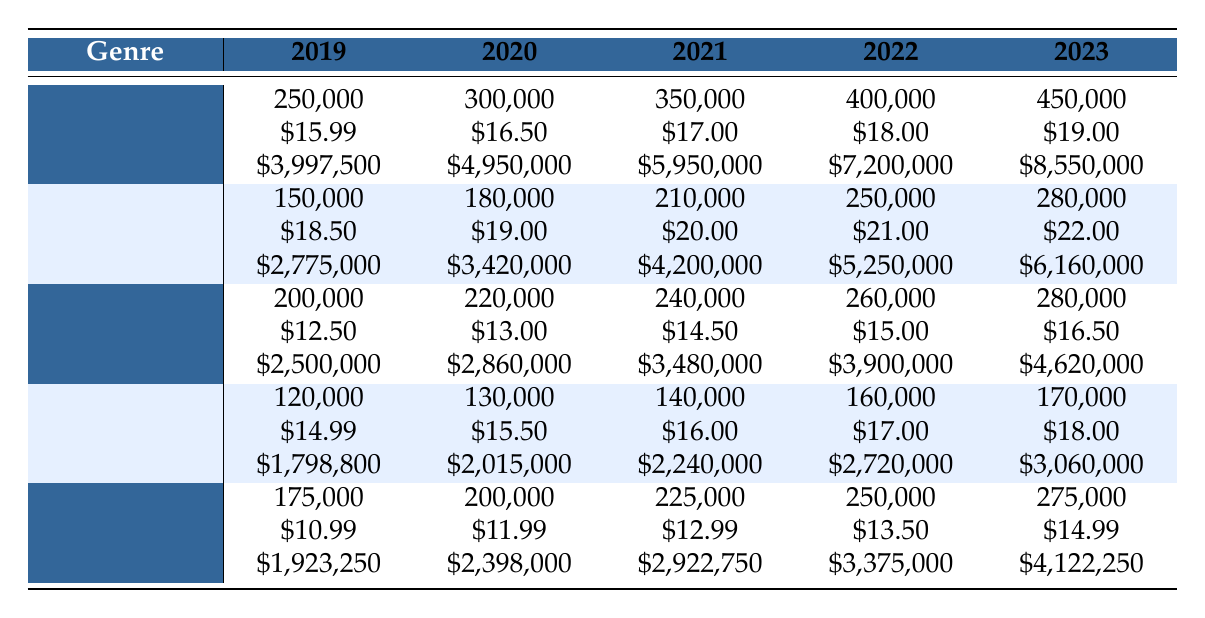What was the total revenue from Fiction sales in 2022? The revenue for Fiction in 2022 is listed directly in the table. According to the table, the revenue for Fiction in 2022 was \$7,200,000.
Answer: 7200000 Which genre had the lowest sales units in 2019? The sales units for each genre in 2019 are presented in the table. Fiction sold 250,000, Non-Fiction sold 150,000, Fantasy sold 200,000, Mystery sold 120,000, and Young Adult sold 175,000. Mystery had the lowest sales units at 120,000.
Answer: Mystery What is the average sales unit for Young Adult across all years? The sales units for Young Adult over five years are: 175,000 (2019), 200,000 (2020), 225,000 (2021), 250,000 (2022), and 275,000 (2023). To calculate the average, sum these values to get 1,125,000 and divide by 5, resulting in 225,000.
Answer: 225000 Did Non-Fiction sales increase every year from 2019 to 2023? By examining the sales units in the table: Non-Fiction units were 150,000 in 2019, 180,000 in 2020, 210,000 in 2021, 250,000 in 2022, and 280,000 in 2023. Each year shows a consistent increase, indicating that Non-Fiction sales did indeed increase every year.
Answer: Yes What was the percentage increase in average price for Fantasy from 2019 to 2023? The average price for Fantasy in 2019 was \$12.50, and in 2023 it was \$16.50. To find the percentage increase, subtract the old value from the new (\$16.50 - \$12.50 = \$4.00), divide by the old value (\$4.00 / \$12.50 = 0.32), and multiply by 100 to convert to a percentage, resulting in a 32% increase.
Answer: 32% 